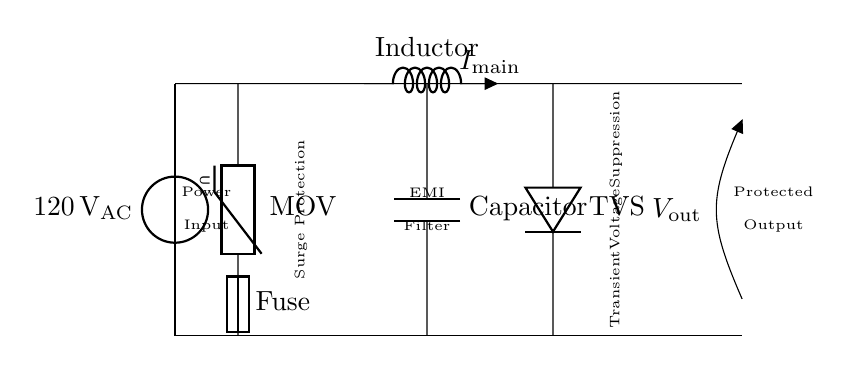What is the input voltage for this circuit? The input voltage is labeled as 120 volts AC, which is indicated at the power source in the diagram.
Answer: 120 volts AC What component is used for surge protection? The circuit diagram indicates a metal-oxide varistor (MOV) is used for surge protection, shown between the power source and the fuse.
Answer: MOV What does TVS stand for in this circuit? The abbreviation TVS in the diagram stands for transient voltage suppression, which is the function of the diode depicted in the circuit.
Answer: Transient voltage suppression How many main components are used before the protected output? The circuit features four main components before reaching the protected output: MOV, fuse, inductor, and capacitor. These are crucial for filtering and protection.
Answer: Four What is the purpose of the inductor in this circuit? The inductor is used for EMI filtering within this surge protector circuit, helping to minimize electromagnetic interference from the power source.
Answer: EMI filtering What is the current labeled in the circuit? The current flowing in the main line is labeled as I main, as indicated in the circuit diagram next to the connection line.
Answer: I main Which component is directly after the surge protector in the circuit? The fuse is located directly after the MOV in the circuit, serving as a safety device to protect against excessive current flow.
Answer: Fuse 